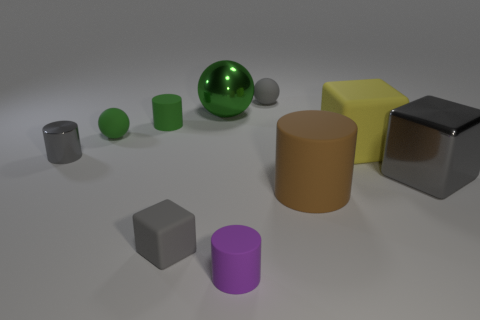Subtract 1 cylinders. How many cylinders are left? 3 Subtract all spheres. How many objects are left? 7 Add 1 spheres. How many spheres are left? 4 Add 6 small shiny cylinders. How many small shiny cylinders exist? 7 Subtract 0 brown balls. How many objects are left? 10 Subtract all purple matte things. Subtract all big purple cylinders. How many objects are left? 9 